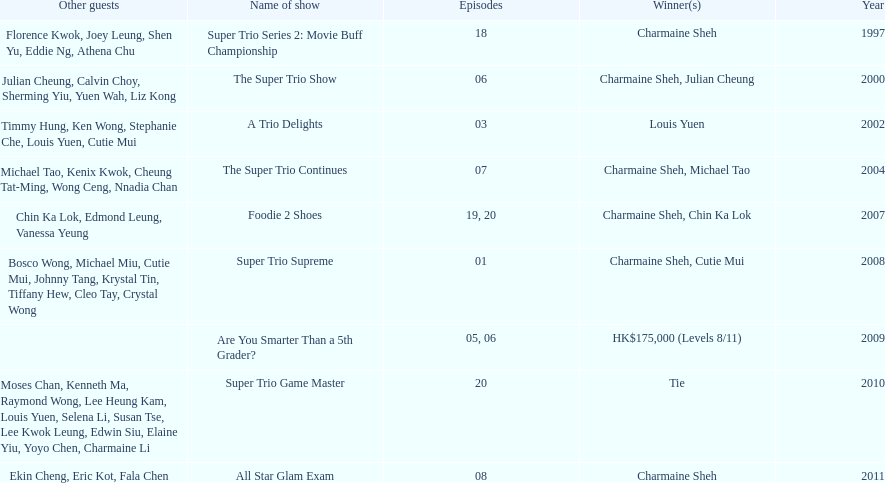What was the total number of trio series shows were charmaine sheh on? 6. 